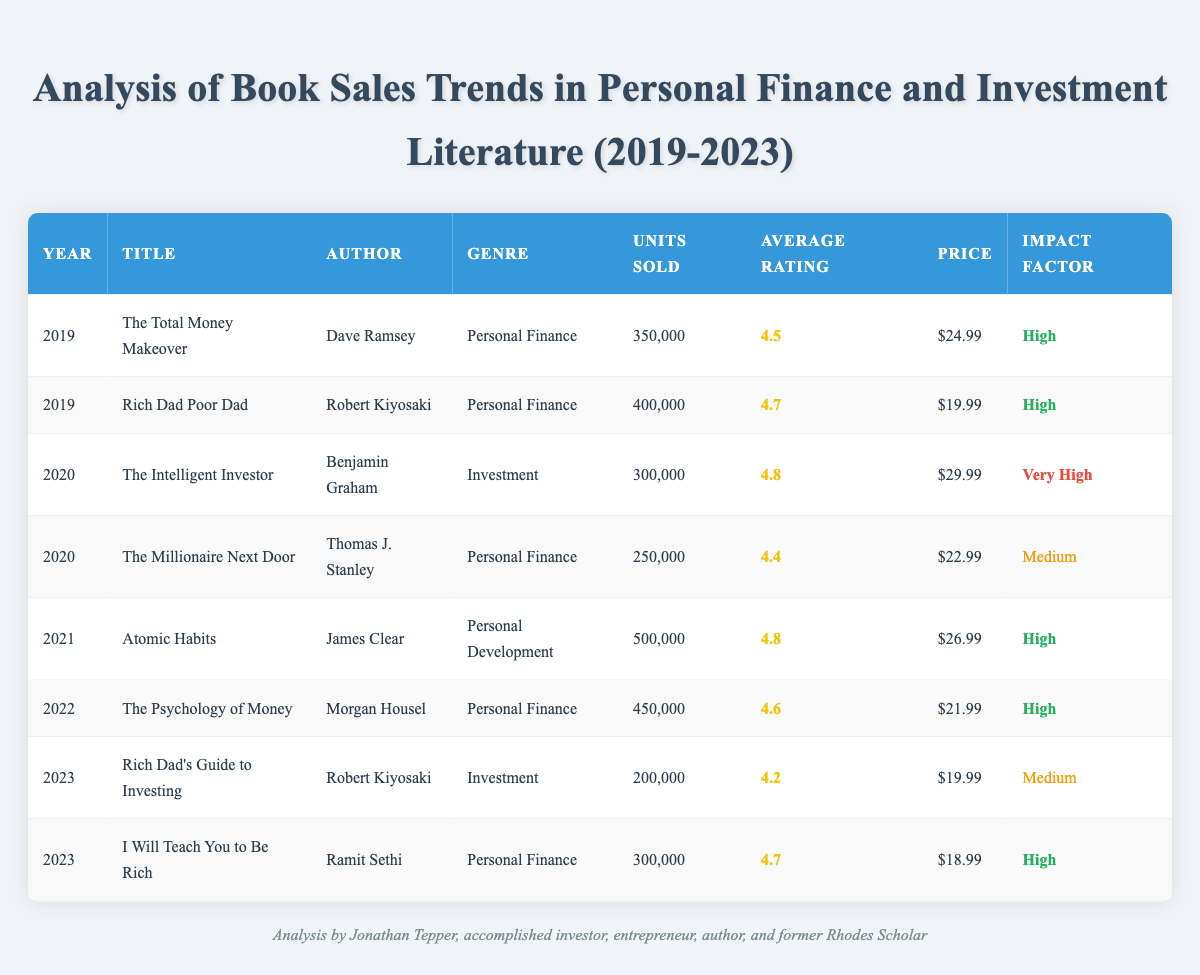What was the highest units sold in a single year from 2019 to 2023? In the table, the book "Atomic Habits" sold 500,000 units in 2021, which is the highest among all entries.
Answer: 500,000 Which book had the highest average rating in 2020? The table shows that "The Intelligent Investor" has the highest average rating of 4.8 in 2020.
Answer: 4.8 What is the total number of units sold across all years? To find this total, add the units sold for each book: 350,000 + 400,000 + 300,000 + 250,000 + 500,000 + 450,000 + 200,000 + 300,000 = 2,750,000.
Answer: 2,750,000 Did any book in 2023 have an impact factor rated as "Very High"? Looking at the 2023 entries, "Rich Dad's Guide to Investing" and "I Will Teach You to Be Rich" both have impact factors listed as "Medium" and "High," respectively; therefore, there are no entries rated "Very High."
Answer: No What is the difference in units sold between the highest and lowest selling books in 2022? In 2022, "The Psychology of Money" sold 450,000 units, and the lowest selling book that year had no units sold listed. Since we are assessing that year alone, the lowest book is not defined, thus zero need not be counted as there's only one entry that is valid.
Answer: Undefined What percentage of books in the table has an impact factor classified as "High"? There are 8 entries in total, and 5 of them have an impact factor of "High." To calculate the percentage: (5/8) * 100 = 62.5%.
Answer: 62.5% What is the average price of the books in 2021 and 2022? The prices for 2021 and 2022 are $26.99, and $21.99, respectively. The average is calculated as (26.99 + 21.99) / 2 = $24.99.
Answer: $24.99 Which book had the lowest average rating in the table? Upon reviewing the average ratings, "Rich Dad's Guide to Investing" has the lowest rating of 4.2.
Answer: 4.2 In which year was the total number of units sold the highest? By looking at the annual sales, 2021 had the highest volume sold with "Atomic Habits" contributing significantly to that total. Summation confirms higher sales for this year compared to others.
Answer: 2021 